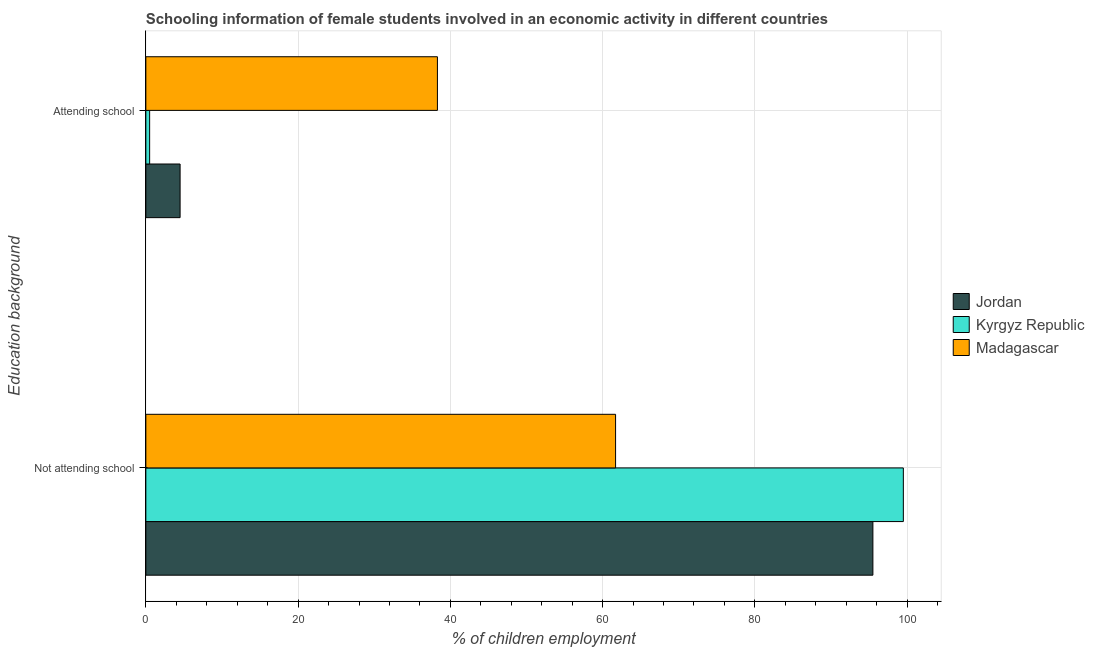How many different coloured bars are there?
Offer a terse response. 3. Are the number of bars on each tick of the Y-axis equal?
Offer a terse response. Yes. How many bars are there on the 1st tick from the top?
Your answer should be very brief. 3. How many bars are there on the 2nd tick from the bottom?
Your answer should be compact. 3. What is the label of the 2nd group of bars from the top?
Your answer should be compact. Not attending school. What is the percentage of employed females who are not attending school in Jordan?
Ensure brevity in your answer.  95.5. Across all countries, what is the maximum percentage of employed females who are attending school?
Your answer should be compact. 38.3. In which country was the percentage of employed females who are attending school maximum?
Offer a terse response. Madagascar. In which country was the percentage of employed females who are attending school minimum?
Give a very brief answer. Kyrgyz Republic. What is the total percentage of employed females who are not attending school in the graph?
Your response must be concise. 256.7. What is the difference between the percentage of employed females who are attending school in Jordan and that in Madagascar?
Provide a succinct answer. -33.8. What is the difference between the percentage of employed females who are attending school in Kyrgyz Republic and the percentage of employed females who are not attending school in Madagascar?
Provide a succinct answer. -61.2. What is the average percentage of employed females who are attending school per country?
Offer a terse response. 14.43. What is the difference between the percentage of employed females who are not attending school and percentage of employed females who are attending school in Kyrgyz Republic?
Keep it short and to the point. 99. In how many countries, is the percentage of employed females who are not attending school greater than 44 %?
Give a very brief answer. 3. What is the ratio of the percentage of employed females who are not attending school in Kyrgyz Republic to that in Madagascar?
Offer a very short reply. 1.61. What does the 3rd bar from the top in Attending school represents?
Provide a succinct answer. Jordan. What does the 3rd bar from the bottom in Attending school represents?
Make the answer very short. Madagascar. How many bars are there?
Provide a short and direct response. 6. Are all the bars in the graph horizontal?
Offer a terse response. Yes. How many countries are there in the graph?
Make the answer very short. 3. What is the difference between two consecutive major ticks on the X-axis?
Make the answer very short. 20. Does the graph contain grids?
Your answer should be very brief. Yes. How are the legend labels stacked?
Provide a succinct answer. Vertical. What is the title of the graph?
Your answer should be very brief. Schooling information of female students involved in an economic activity in different countries. What is the label or title of the X-axis?
Make the answer very short. % of children employment. What is the label or title of the Y-axis?
Offer a very short reply. Education background. What is the % of children employment of Jordan in Not attending school?
Offer a very short reply. 95.5. What is the % of children employment of Kyrgyz Republic in Not attending school?
Ensure brevity in your answer.  99.5. What is the % of children employment in Madagascar in Not attending school?
Provide a succinct answer. 61.7. What is the % of children employment of Jordan in Attending school?
Provide a succinct answer. 4.5. What is the % of children employment in Kyrgyz Republic in Attending school?
Ensure brevity in your answer.  0.5. What is the % of children employment of Madagascar in Attending school?
Provide a succinct answer. 38.3. Across all Education background, what is the maximum % of children employment of Jordan?
Make the answer very short. 95.5. Across all Education background, what is the maximum % of children employment of Kyrgyz Republic?
Make the answer very short. 99.5. Across all Education background, what is the maximum % of children employment in Madagascar?
Make the answer very short. 61.7. Across all Education background, what is the minimum % of children employment of Madagascar?
Your answer should be compact. 38.3. What is the total % of children employment of Madagascar in the graph?
Offer a terse response. 100. What is the difference between the % of children employment in Jordan in Not attending school and that in Attending school?
Offer a terse response. 91. What is the difference between the % of children employment in Kyrgyz Republic in Not attending school and that in Attending school?
Your response must be concise. 99. What is the difference between the % of children employment of Madagascar in Not attending school and that in Attending school?
Your answer should be compact. 23.4. What is the difference between the % of children employment in Jordan in Not attending school and the % of children employment in Madagascar in Attending school?
Your response must be concise. 57.2. What is the difference between the % of children employment of Kyrgyz Republic in Not attending school and the % of children employment of Madagascar in Attending school?
Your response must be concise. 61.2. What is the average % of children employment in Jordan per Education background?
Make the answer very short. 50. What is the average % of children employment of Madagascar per Education background?
Your response must be concise. 50. What is the difference between the % of children employment in Jordan and % of children employment in Madagascar in Not attending school?
Offer a very short reply. 33.8. What is the difference between the % of children employment in Kyrgyz Republic and % of children employment in Madagascar in Not attending school?
Your response must be concise. 37.8. What is the difference between the % of children employment in Jordan and % of children employment in Kyrgyz Republic in Attending school?
Your answer should be very brief. 4. What is the difference between the % of children employment of Jordan and % of children employment of Madagascar in Attending school?
Your answer should be compact. -33.8. What is the difference between the % of children employment of Kyrgyz Republic and % of children employment of Madagascar in Attending school?
Give a very brief answer. -37.8. What is the ratio of the % of children employment of Jordan in Not attending school to that in Attending school?
Your response must be concise. 21.22. What is the ratio of the % of children employment in Kyrgyz Republic in Not attending school to that in Attending school?
Keep it short and to the point. 199. What is the ratio of the % of children employment in Madagascar in Not attending school to that in Attending school?
Your response must be concise. 1.61. What is the difference between the highest and the second highest % of children employment of Jordan?
Give a very brief answer. 91. What is the difference between the highest and the second highest % of children employment of Kyrgyz Republic?
Your answer should be very brief. 99. What is the difference between the highest and the second highest % of children employment of Madagascar?
Provide a succinct answer. 23.4. What is the difference between the highest and the lowest % of children employment in Jordan?
Offer a terse response. 91. What is the difference between the highest and the lowest % of children employment of Kyrgyz Republic?
Offer a terse response. 99. What is the difference between the highest and the lowest % of children employment of Madagascar?
Give a very brief answer. 23.4. 